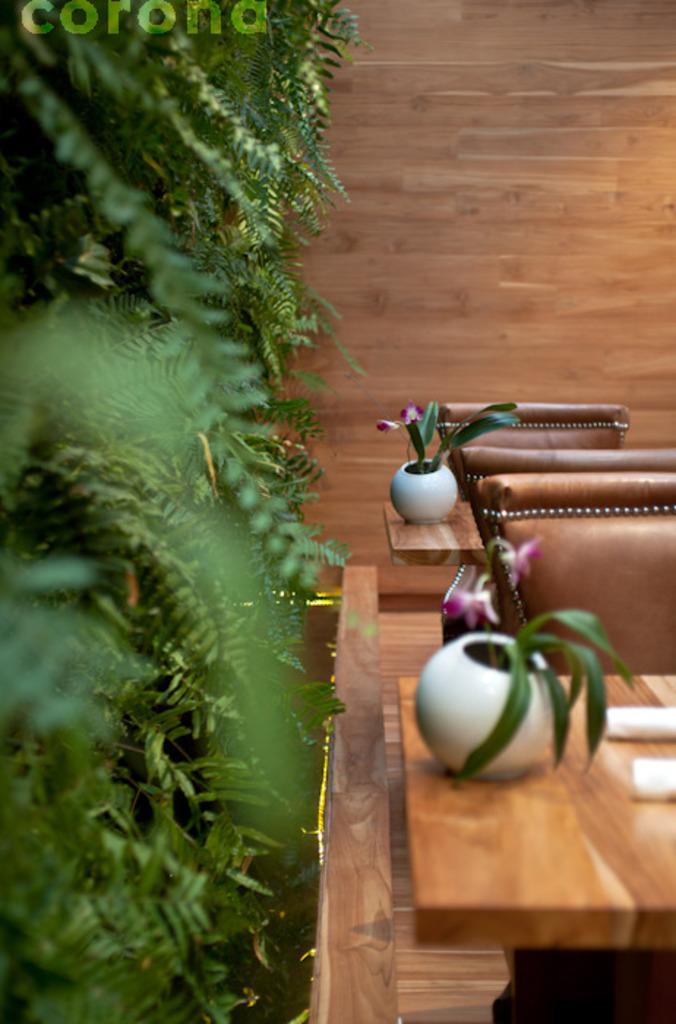Can you describe this image briefly? In the foreground I can see a table, chairs and houseplants. In the background I can see trees and a wooden wall. This image is taken may be during a day. 